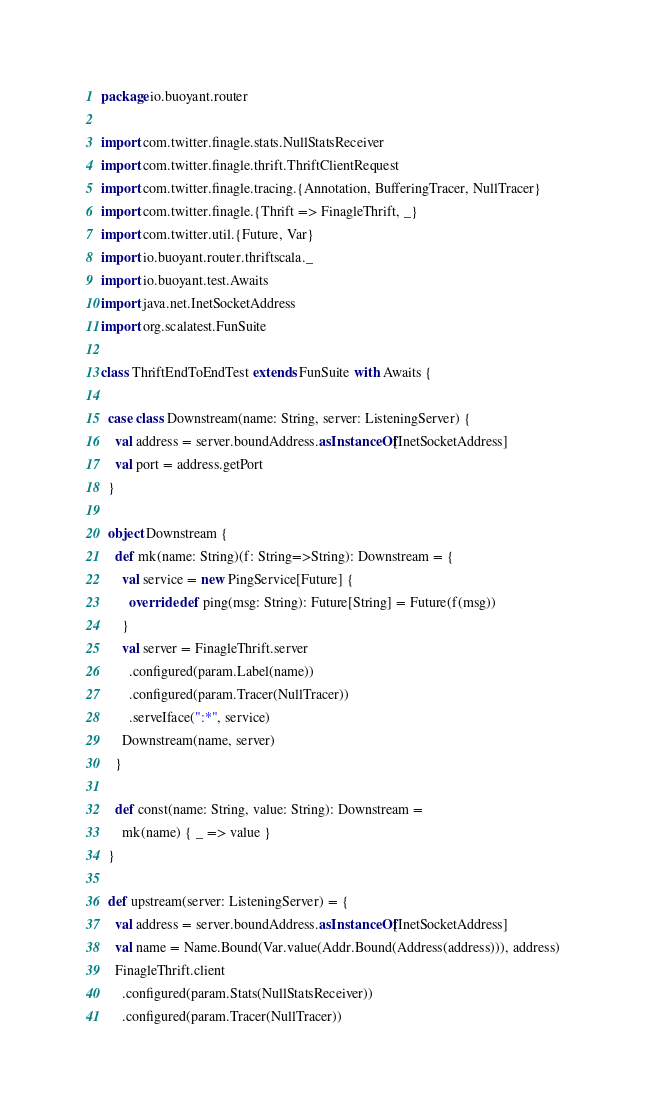Convert code to text. <code><loc_0><loc_0><loc_500><loc_500><_Scala_>package io.buoyant.router

import com.twitter.finagle.stats.NullStatsReceiver
import com.twitter.finagle.thrift.ThriftClientRequest
import com.twitter.finagle.tracing.{Annotation, BufferingTracer, NullTracer}
import com.twitter.finagle.{Thrift => FinagleThrift, _}
import com.twitter.util.{Future, Var}
import io.buoyant.router.thriftscala._
import io.buoyant.test.Awaits
import java.net.InetSocketAddress
import org.scalatest.FunSuite

class ThriftEndToEndTest extends FunSuite with Awaits {

  case class Downstream(name: String, server: ListeningServer) {
    val address = server.boundAddress.asInstanceOf[InetSocketAddress]
    val port = address.getPort
  }

  object Downstream {
    def mk(name: String)(f: String=>String): Downstream = {
      val service = new PingService[Future] {
        override def ping(msg: String): Future[String] = Future(f(msg))
      }
      val server = FinagleThrift.server
        .configured(param.Label(name))
        .configured(param.Tracer(NullTracer))
        .serveIface(":*", service)
      Downstream(name, server)
    }

    def const(name: String, value: String): Downstream =
      mk(name) { _ => value }
  }

  def upstream(server: ListeningServer) = {
    val address = server.boundAddress.asInstanceOf[InetSocketAddress]
    val name = Name.Bound(Var.value(Addr.Bound(Address(address))), address)
    FinagleThrift.client
      .configured(param.Stats(NullStatsReceiver))
      .configured(param.Tracer(NullTracer))</code> 